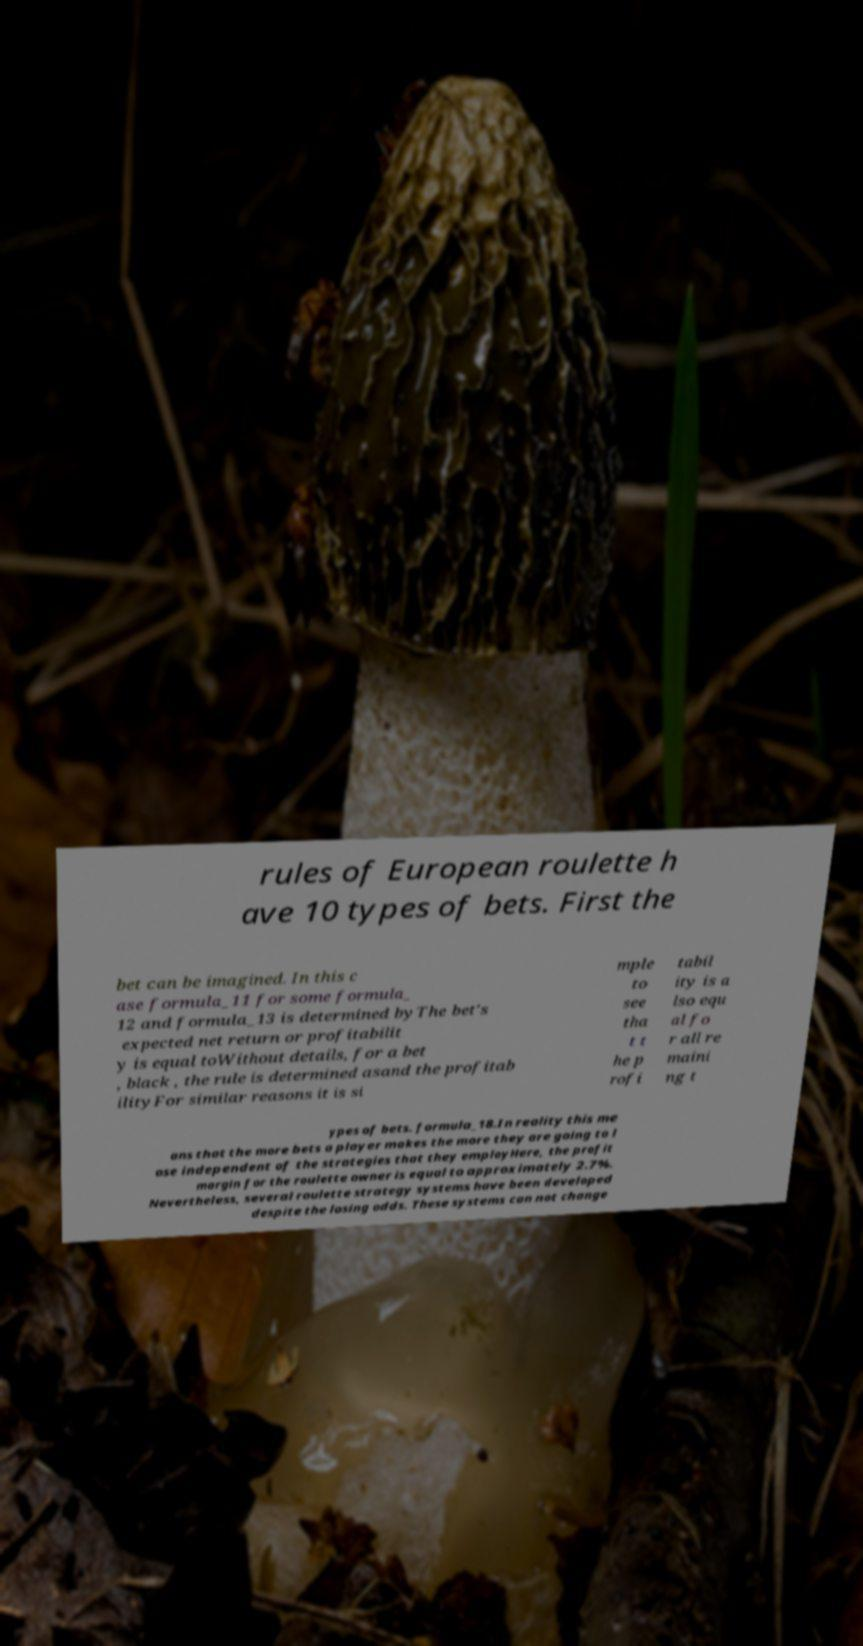What messages or text are displayed in this image? I need them in a readable, typed format. rules of European roulette h ave 10 types of bets. First the bet can be imagined. In this c ase formula_11 for some formula_ 12 and formula_13 is determined byThe bet's expected net return or profitabilit y is equal toWithout details, for a bet , black , the rule is determined asand the profitab ilityFor similar reasons it is si mple to see tha t t he p rofi tabil ity is a lso equ al fo r all re maini ng t ypes of bets. formula_18.In reality this me ans that the more bets a player makes the more they are going to l ose independent of the strategies that they employHere, the profit margin for the roulette owner is equal to approximately 2.7%. Nevertheless, several roulette strategy systems have been developed despite the losing odds. These systems can not change 